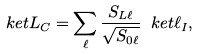<formula> <loc_0><loc_0><loc_500><loc_500>\ k e t { L } _ { C } = \sum _ { \ell } \frac { S _ { L \ell } } { \sqrt { S _ { 0 \ell } } } \ k e t { \ell } _ { I } ,</formula> 